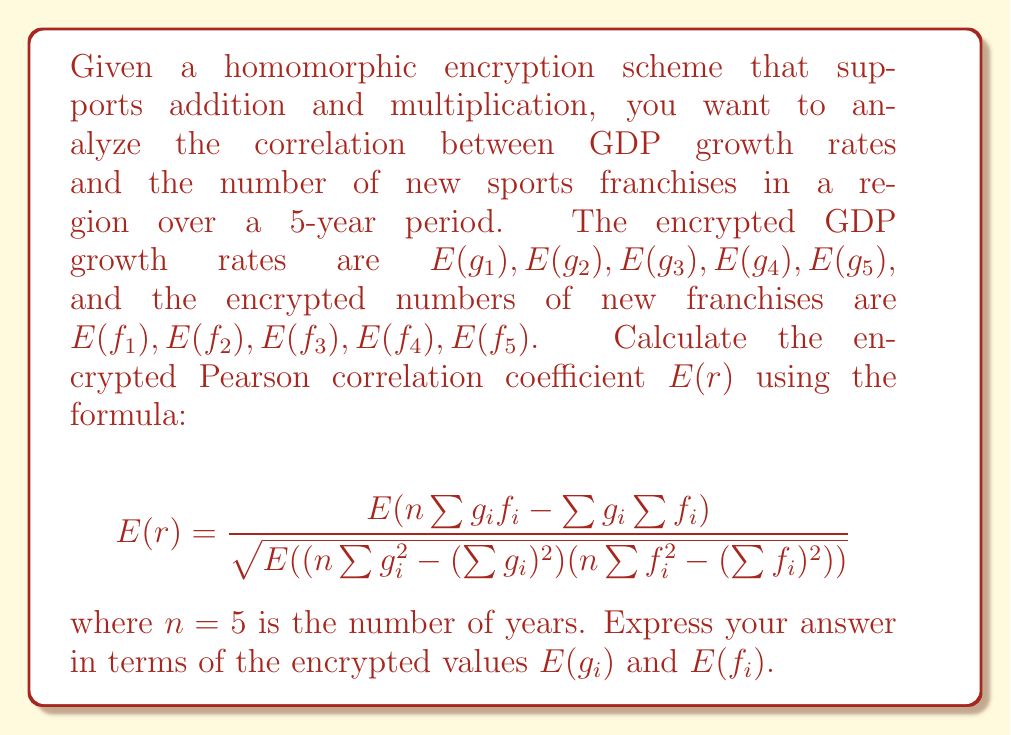Provide a solution to this math problem. To calculate the encrypted Pearson correlation coefficient using homomorphic encryption, we'll follow these steps:

1) First, we need to compute the following terms:
   
   $E(\sum g_i) = E(g_1) + E(g_2) + E(g_3) + E(g_4) + E(g_5)$
   $E(\sum f_i) = E(f_1) + E(f_2) + E(f_3) + E(f_4) + E(f_5)$
   
   $E(\sum g_i^2) = E(g_1)^2 + E(g_2)^2 + E(g_3)^2 + E(g_4)^2 + E(g_5)^2$
   $E(\sum f_i^2) = E(f_1)^2 + E(f_2)^2 + E(f_3)^2 + E(f_4)^2 + E(f_5)^2$
   
   $E(\sum g_if_i) = E(g_1)E(f_1) + E(g_2)E(f_2) + E(g_3)E(f_3) + E(g_4)E(f_4) + E(g_5)E(f_5)$

2) Now, we can compute the numerator:
   
   $E(n\sum g_if_i - \sum g_i \sum f_i) = 5E(\sum g_if_i) - E(\sum g_i)E(\sum f_i)$

3) For the denominator, we compute:
   
   $E(n\sum g_i^2 - (\sum g_i)^2) = 5E(\sum g_i^2) - E(\sum g_i)^2$
   $E(n\sum f_i^2 - (\sum f_i)^2) = 5E(\sum f_i^2) - E(\sum f_i)^2$

4) The product of these terms gives us the denominator:
   
   $E((n\sum g_i^2 - (\sum g_i)^2)(n\sum f_i^2 - (\sum f_i)^2)) = (5E(\sum g_i^2) - E(\sum g_i)^2)(5E(\sum f_i^2) - E(\sum f_i)^2)$

5) Finally, we take the square root of the denominator and divide the numerator by it to get $E(r)$.

Note that all operations are performed on encrypted values, leveraging the homomorphic properties of the encryption scheme.
Answer: $$E(r) = \frac{5E(\sum g_if_i) - E(\sum g_i)E(\sum f_i)}{\sqrt{(5E(\sum g_i^2) - E(\sum g_i)^2)(5E(\sum f_i^2) - E(\sum f_i)^2)}}$$ 